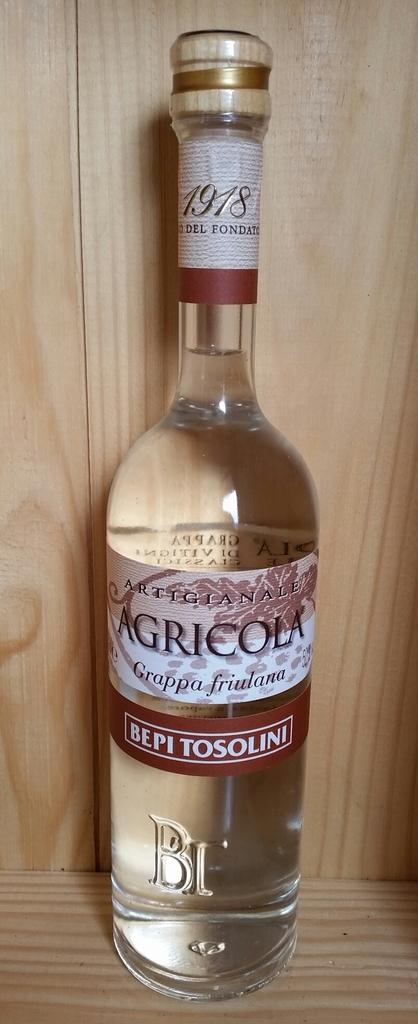What is the main object in the image? There is a wine bottle in the image. What type of worm can be seen playing the instrument in the image? There is no worm or instrument present in the image; it only features a wine bottle. 